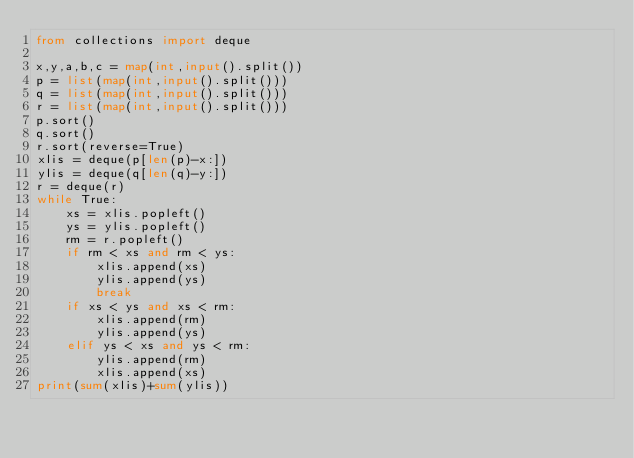Convert code to text. <code><loc_0><loc_0><loc_500><loc_500><_Python_>from collections import deque

x,y,a,b,c = map(int,input().split())
p = list(map(int,input().split()))
q = list(map(int,input().split()))
r = list(map(int,input().split()))
p.sort()
q.sort()
r.sort(reverse=True)
xlis = deque(p[len(p)-x:])
ylis = deque(q[len(q)-y:])
r = deque(r)
while True:
    xs = xlis.popleft()
    ys = ylis.popleft()
    rm = r.popleft()
    if rm < xs and rm < ys:
        xlis.append(xs)
        ylis.append(ys)
        break
    if xs < ys and xs < rm:
        xlis.append(rm)
        ylis.append(ys)
    elif ys < xs and ys < rm:
        ylis.append(rm)
        xlis.append(xs) 
print(sum(xlis)+sum(ylis))</code> 